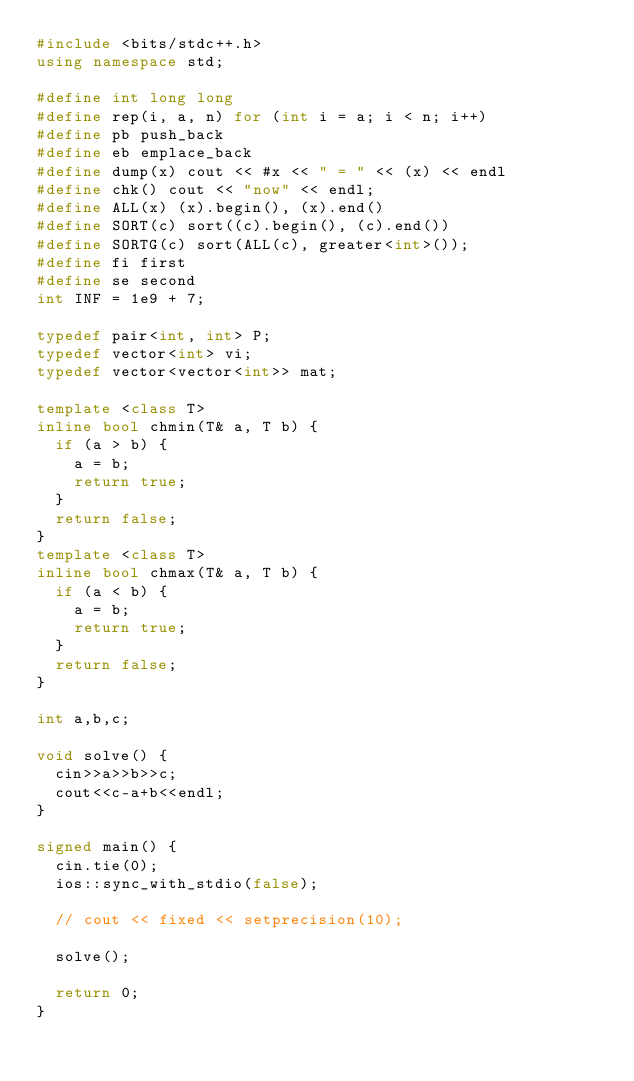<code> <loc_0><loc_0><loc_500><loc_500><_C++_>#include <bits/stdc++.h>
using namespace std;

#define int long long
#define rep(i, a, n) for (int i = a; i < n; i++)
#define pb push_back
#define eb emplace_back
#define dump(x) cout << #x << " = " << (x) << endl
#define chk() cout << "now" << endl;
#define ALL(x) (x).begin(), (x).end()
#define SORT(c) sort((c).begin(), (c).end())
#define SORTG(c) sort(ALL(c), greater<int>());
#define fi first
#define se second
int INF = 1e9 + 7;

typedef pair<int, int> P;
typedef vector<int> vi;
typedef vector<vector<int>> mat;

template <class T>
inline bool chmin(T& a, T b) {
  if (a > b) {
    a = b;
    return true;
  }
  return false;
}
template <class T>
inline bool chmax(T& a, T b) {
  if (a < b) {
    a = b;
    return true;
  }
  return false;
}

int a,b,c;

void solve() {
  cin>>a>>b>>c;
  cout<<c-a+b<<endl;
}

signed main() {
  cin.tie(0);
  ios::sync_with_stdio(false);

  // cout << fixed << setprecision(10);

  solve();

  return 0;
}
</code> 